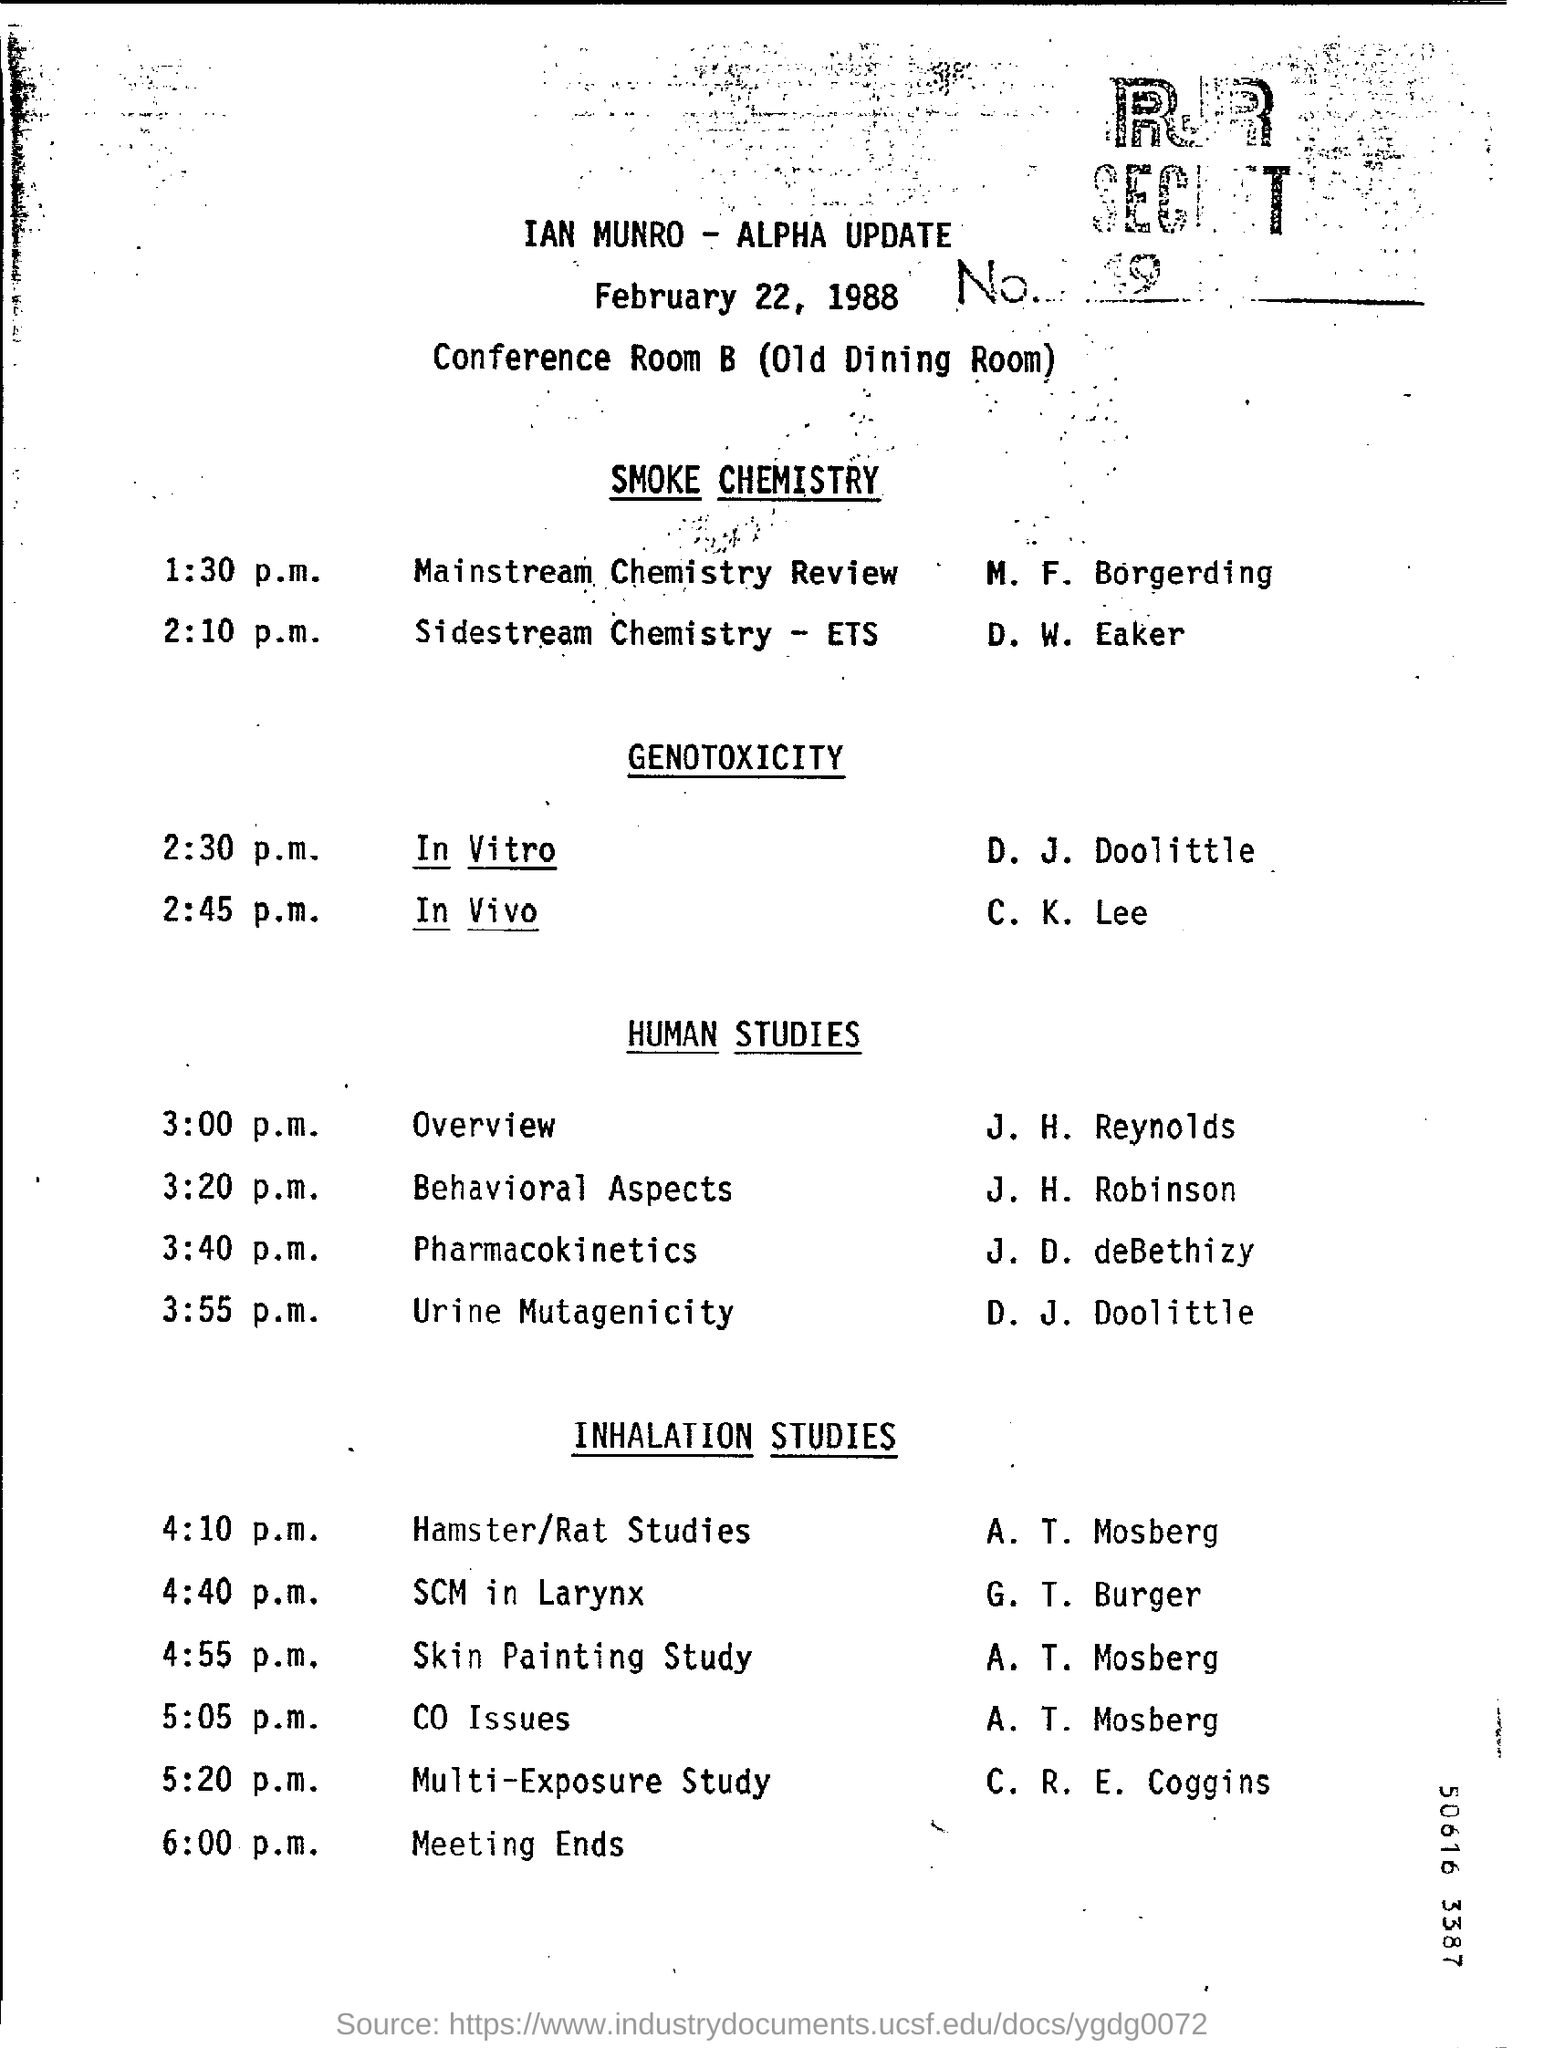What is the date mentioned in the top of the document ?
Offer a terse response. February  22, 1988. 